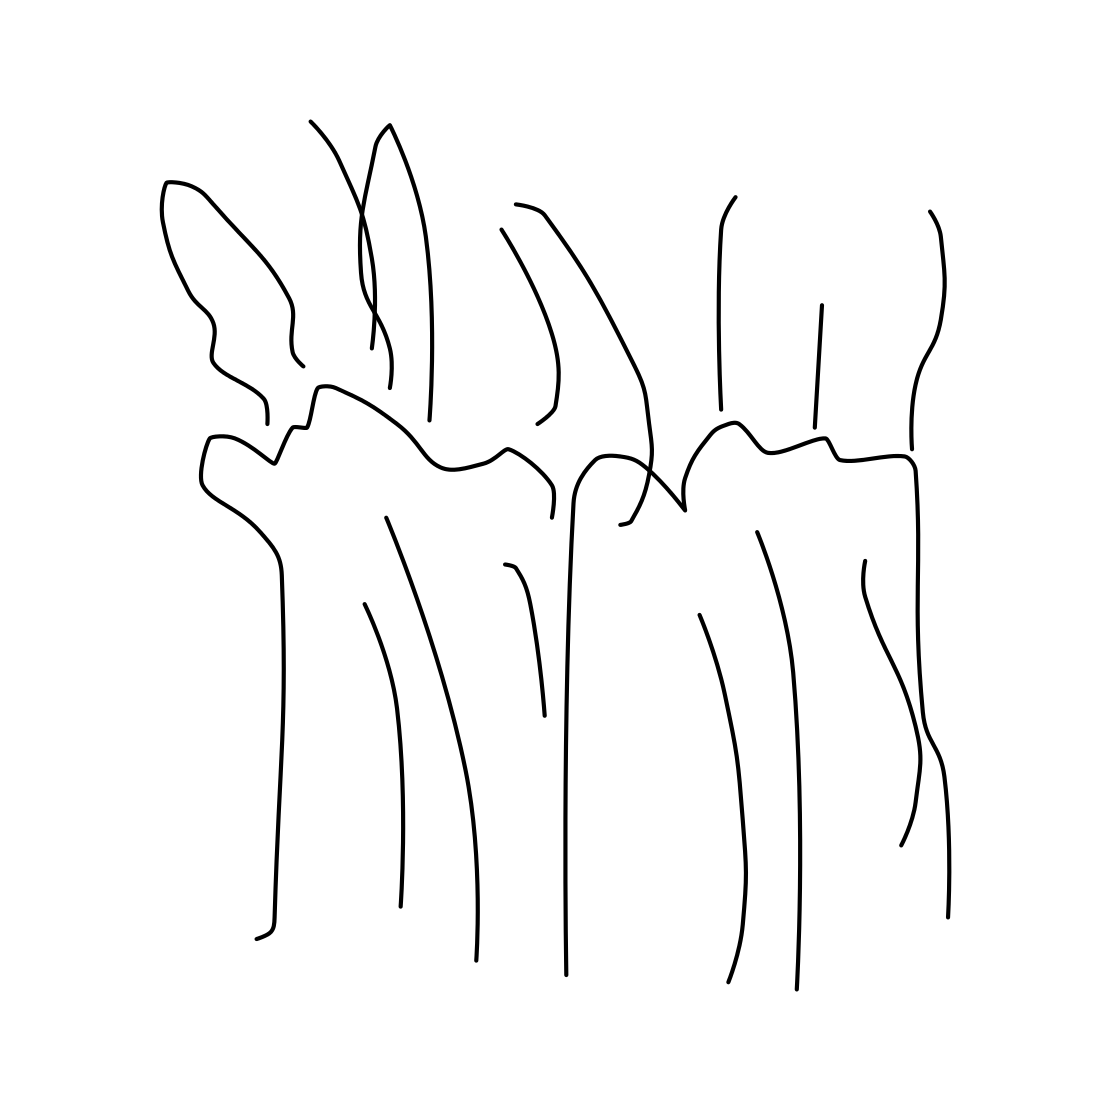What does this drawing represent? The drawing is abstract and open to interpretation. It might symbolize organic forms, such as plants growing together or an underwater scene with different types of sea life. The flowing lines create a sense of movement and continuity. 